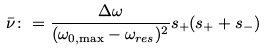Convert formula to latex. <formula><loc_0><loc_0><loc_500><loc_500>\bar { \nu } \colon = \frac { \Delta \omega } { ( \omega _ { 0 , { \max } } - \omega _ { r e s } ) ^ { 2 } } s _ { + } ( s _ { + } + s _ { - } )</formula> 